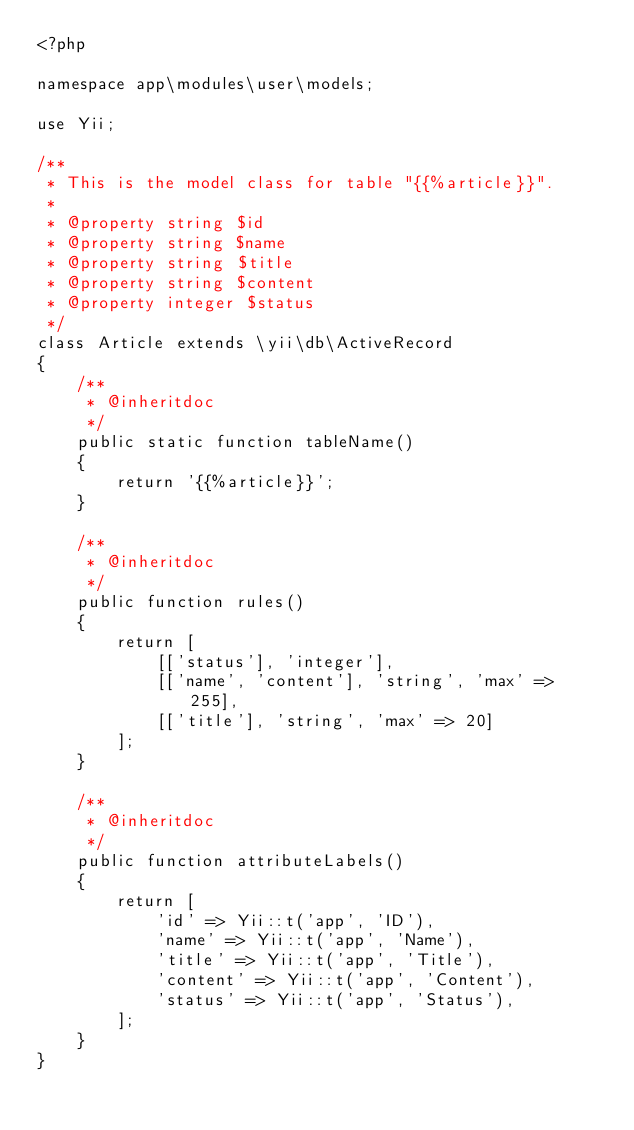<code> <loc_0><loc_0><loc_500><loc_500><_PHP_><?php

namespace app\modules\user\models;

use Yii;

/**
 * This is the model class for table "{{%article}}".
 *
 * @property string $id
 * @property string $name
 * @property string $title
 * @property string $content
 * @property integer $status
 */
class Article extends \yii\db\ActiveRecord
{
    /**
     * @inheritdoc
     */
    public static function tableName()
    {
        return '{{%article}}';
    }

    /**
     * @inheritdoc
     */
    public function rules()
    {
        return [
            [['status'], 'integer'],
            [['name', 'content'], 'string', 'max' => 255],
            [['title'], 'string', 'max' => 20]
        ];
    }

    /**
     * @inheritdoc
     */
    public function attributeLabels()
    {
        return [
            'id' => Yii::t('app', 'ID'),
            'name' => Yii::t('app', 'Name'),
            'title' => Yii::t('app', 'Title'),
            'content' => Yii::t('app', 'Content'),
            'status' => Yii::t('app', 'Status'),
        ];
    }
}
</code> 